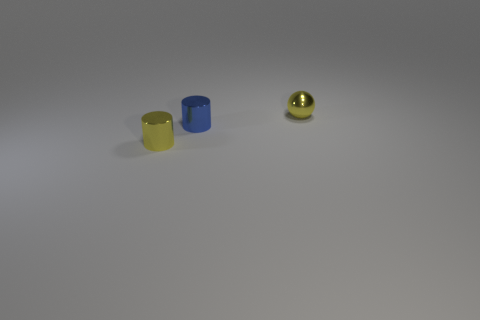What is the shape of the blue thing?
Offer a terse response. Cylinder. Are there the same number of tiny yellow metal balls that are to the left of the yellow shiny ball and blue objects left of the blue metallic object?
Offer a very short reply. Yes. There is a metallic thing to the left of the blue cylinder; is its color the same as the metal cylinder behind the tiny yellow shiny cylinder?
Provide a succinct answer. No. Is the number of small yellow spheres that are in front of the yellow metal cylinder greater than the number of small balls?
Offer a terse response. No. The tiny blue object that is made of the same material as the yellow cylinder is what shape?
Offer a very short reply. Cylinder. There is a thing that is in front of the blue object; is its size the same as the yellow shiny ball?
Provide a short and direct response. Yes. There is a small yellow shiny thing that is on the right side of the small thing in front of the blue object; what shape is it?
Ensure brevity in your answer.  Sphere. What is the size of the yellow object that is on the right side of the tiny yellow object that is in front of the metallic sphere?
Keep it short and to the point. Small. There is a small metallic object on the left side of the small blue cylinder; what color is it?
Your answer should be very brief. Yellow. The yellow object that is the same material as the yellow cylinder is what size?
Make the answer very short. Small. 